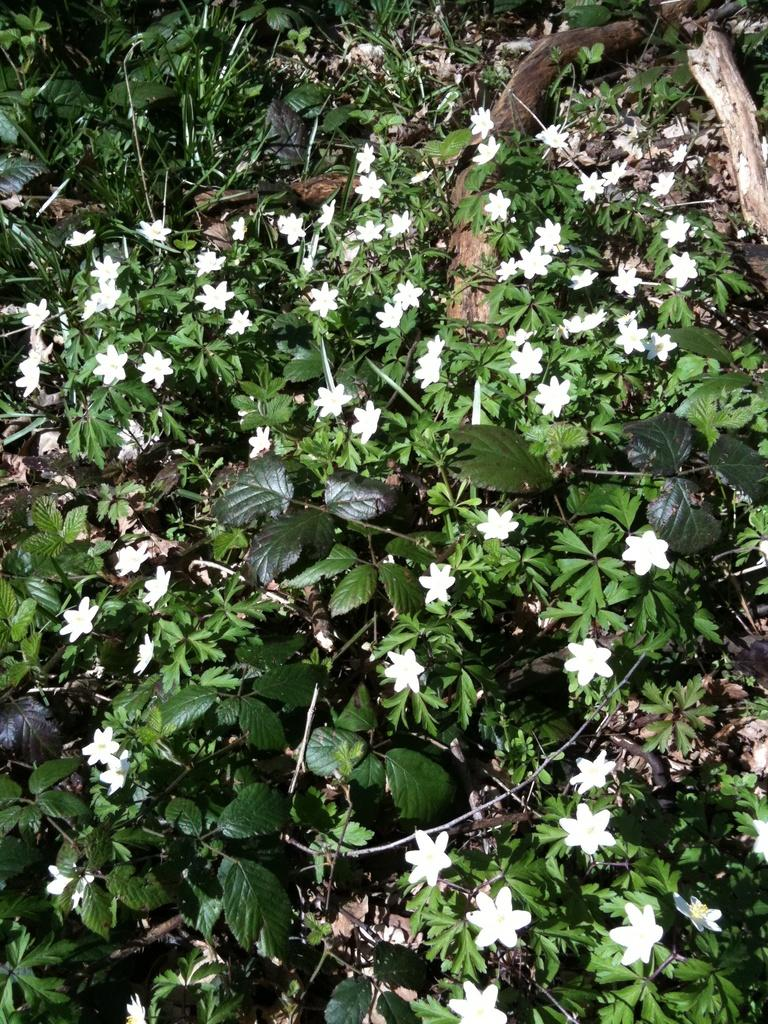What type of plants are in the picture? There are flower plants in the picture. What color are the flowers on the plants? The flowers are white in color. Is there a rabbit serving the flowers in the image? There is no rabbit or any indication of serving in the image; it only features flower plants with white flowers. 